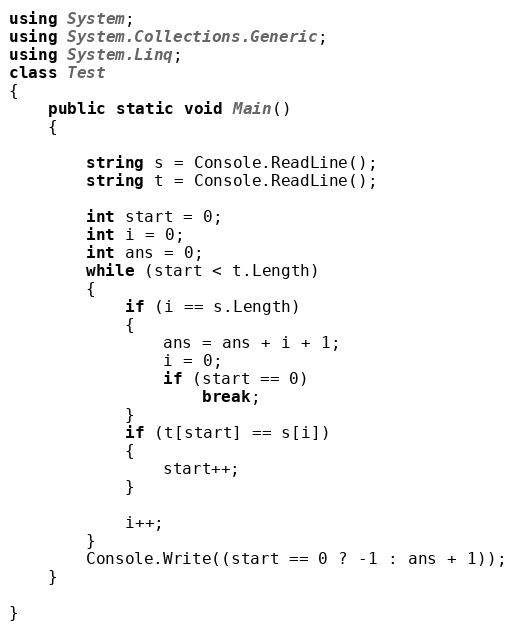<code> <loc_0><loc_0><loc_500><loc_500><_C#_>using System;
using System.Collections.Generic;
using System.Linq;
class Test
{
    public static void Main()
    {

        string s = Console.ReadLine();
        string t = Console.ReadLine();

        int start = 0;
        int i = 0;
        int ans = 0;
        while (start < t.Length)
        {
            if (i == s.Length)
            {
                ans = ans + i + 1;
                i = 0;
                if (start == 0)
                    break;
            }
            if (t[start] == s[i])
            {
                start++;
            }

            i++;
        }
        Console.Write((start == 0 ? -1 : ans + 1));
    }

}


</code> 